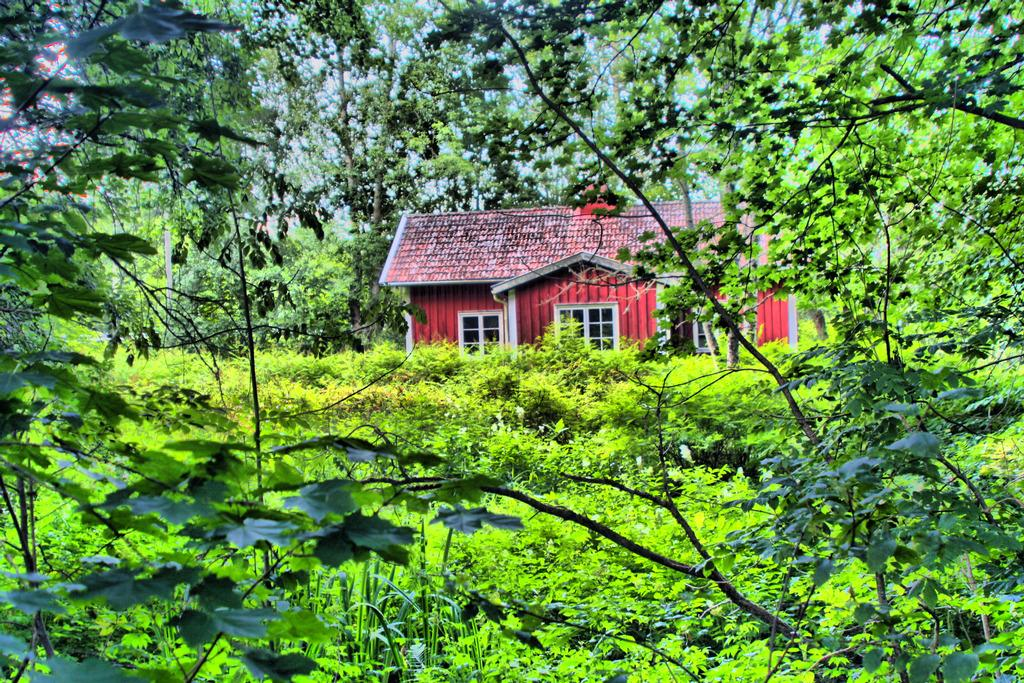What type of vegetation can be seen in the image? There are trees in the image. What structure is located in the middle of the image? There is a house in the middle of the image. Is there a spy hiding behind the trees in the image? There is no indication of a spy or any hidden figure in the image; it only features trees and a house. What type of box is present in the image? There is no box present in the image. 